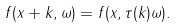Convert formula to latex. <formula><loc_0><loc_0><loc_500><loc_500>f ( x + k , \omega ) = f ( x , \tau ( k ) \omega ) .</formula> 